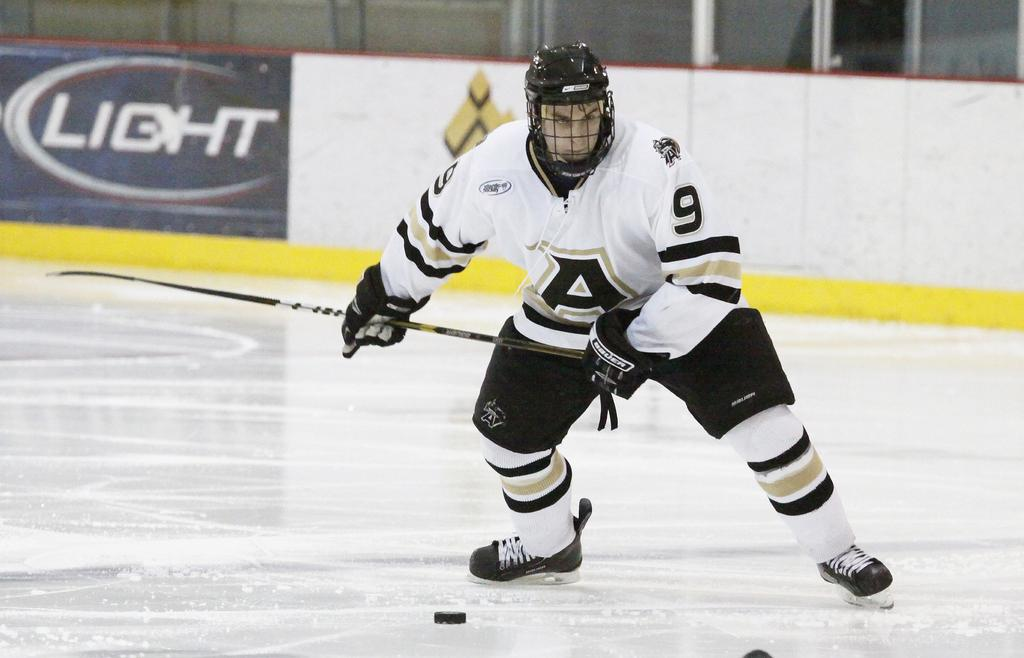What is the main subject of the image? There is a person in the image. What activity is the person engaged in? The person is playing ice skating. What can be seen in the background of the image? There is a wall in the background of the image. What flavor of ice cream is the person's uncle eating in the image? There is no ice cream or uncle present in the image, so it cannot be determined from the image. 